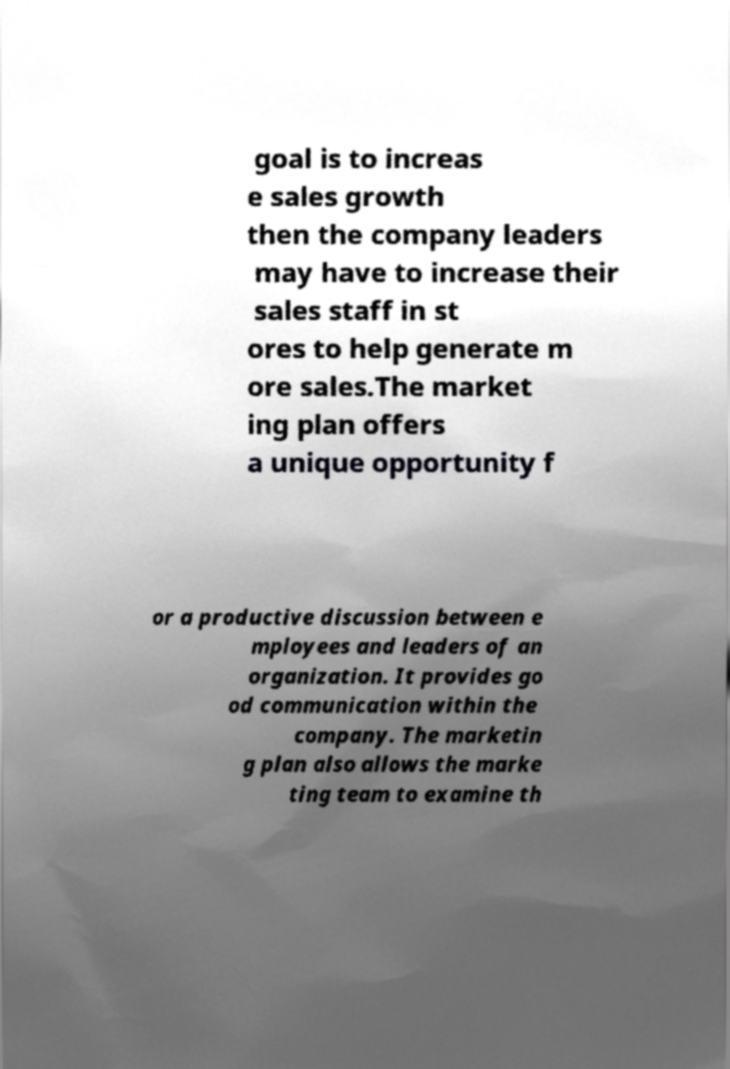What messages or text are displayed in this image? I need them in a readable, typed format. goal is to increas e sales growth then the company leaders may have to increase their sales staff in st ores to help generate m ore sales.The market ing plan offers a unique opportunity f or a productive discussion between e mployees and leaders of an organization. It provides go od communication within the company. The marketin g plan also allows the marke ting team to examine th 